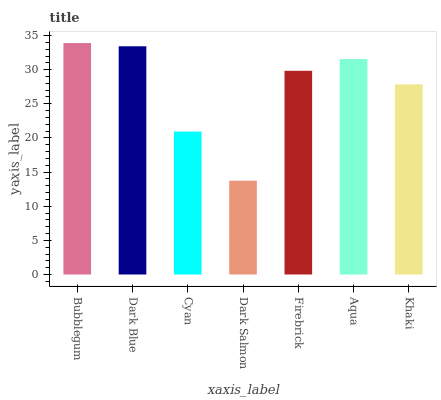Is Dark Salmon the minimum?
Answer yes or no. Yes. Is Bubblegum the maximum?
Answer yes or no. Yes. Is Dark Blue the minimum?
Answer yes or no. No. Is Dark Blue the maximum?
Answer yes or no. No. Is Bubblegum greater than Dark Blue?
Answer yes or no. Yes. Is Dark Blue less than Bubblegum?
Answer yes or no. Yes. Is Dark Blue greater than Bubblegum?
Answer yes or no. No. Is Bubblegum less than Dark Blue?
Answer yes or no. No. Is Firebrick the high median?
Answer yes or no. Yes. Is Firebrick the low median?
Answer yes or no. Yes. Is Cyan the high median?
Answer yes or no. No. Is Cyan the low median?
Answer yes or no. No. 